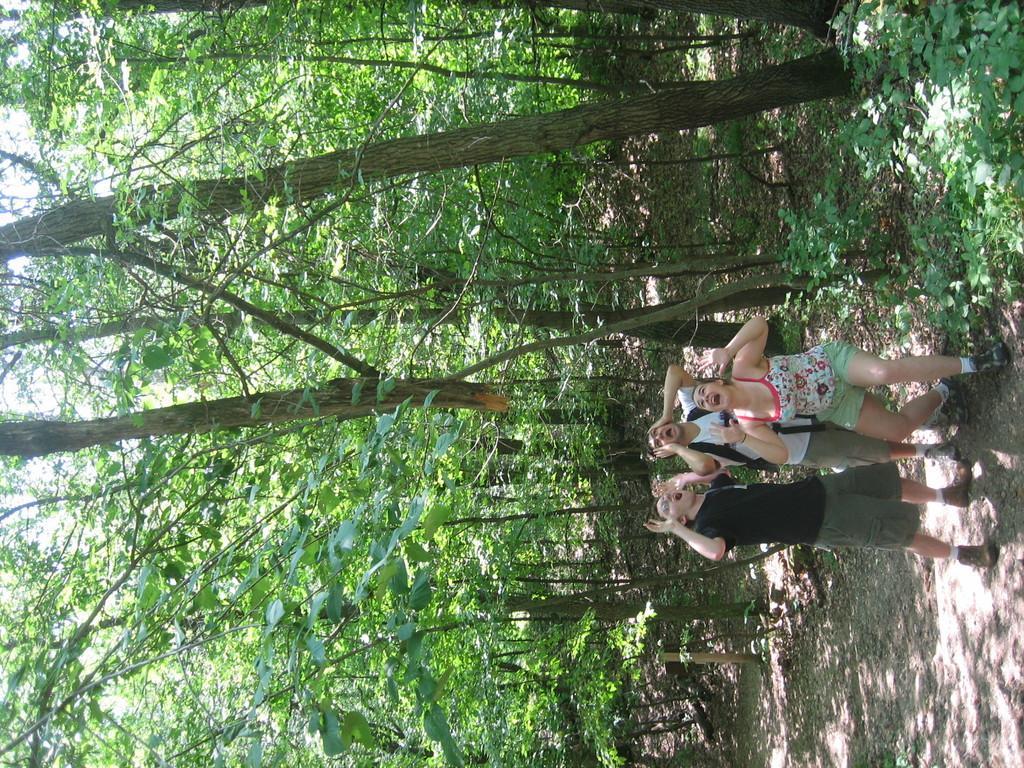In one or two sentences, can you explain what this image depicts? In this image there are three people standing and shouting, behind them there are trees. 